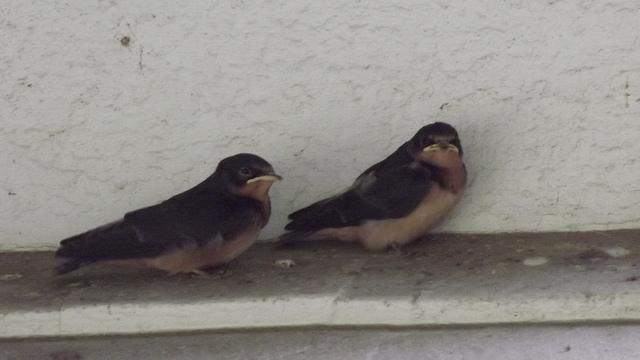How many birds are there?
Give a very brief answer. 2. How many birds are in the photo?
Give a very brief answer. 2. How many people have remotes in their hands?
Give a very brief answer. 0. 